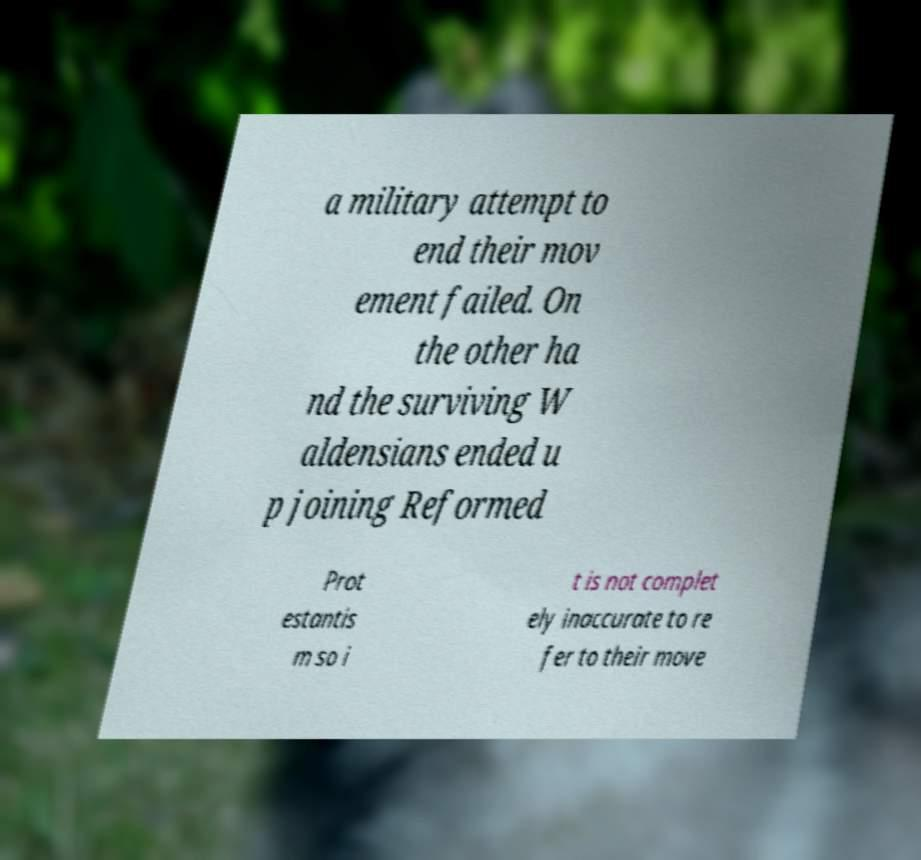I need the written content from this picture converted into text. Can you do that? a military attempt to end their mov ement failed. On the other ha nd the surviving W aldensians ended u p joining Reformed Prot estantis m so i t is not complet ely inaccurate to re fer to their move 